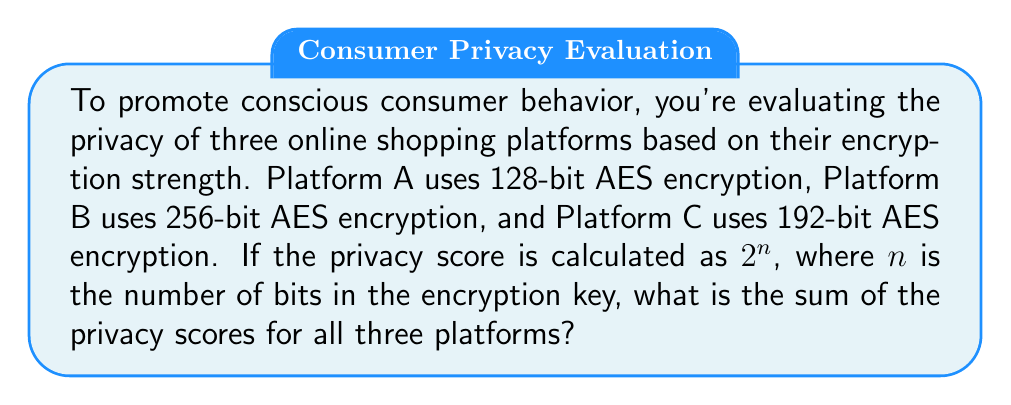Teach me how to tackle this problem. To solve this problem, we need to calculate the privacy score for each platform and then sum them up. Let's go through it step-by-step:

1. Calculate the privacy score for Platform A:
   - Platform A uses 128-bit AES encryption
   - Privacy score = $2^{128}$

2. Calculate the privacy score for Platform B:
   - Platform B uses 256-bit AES encryption
   - Privacy score = $2^{256}$

3. Calculate the privacy score for Platform C:
   - Platform C uses 192-bit AES encryption
   - Privacy score = $2^{192}$

4. Sum up the privacy scores:
   Total privacy score = $2^{128} + 2^{256} + 2^{192}$

5. Simplify the expression:
   Since these are extremely large numbers, we cannot compute their exact decimal values. The sum remains in its exponential form.

Therefore, the final sum of the privacy scores is $2^{128} + 2^{256} + 2^{192}$.
Answer: $2^{128} + 2^{256} + 2^{192}$ 